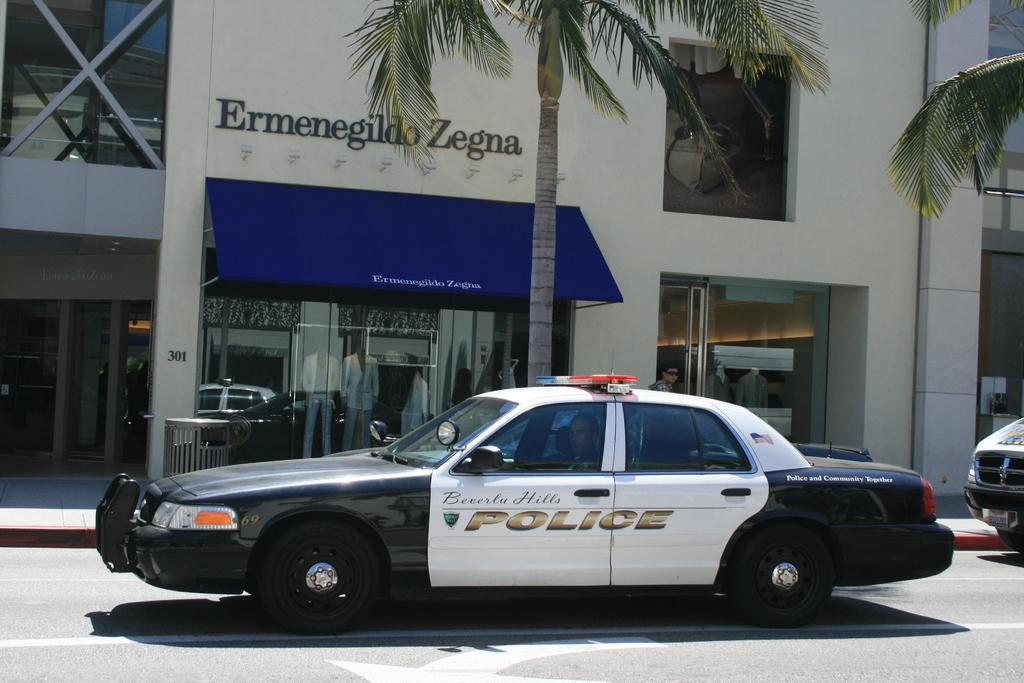What is happening on the road in the image? There are vehicles on the road in the image. Can you describe the occupants of the vehicles? People are seated in at least one car in the image. What can be seen in the background of the image? There are trees, buildings, and metal rods in the background of the image. Are there any human-like figures in the background? Yes, mannequins are visible in the background of the image. What type of jeans are the cats wearing in the image? There are no cats or jeans present in the image. Is there a church visible in the image? There is no church visible in the image. 